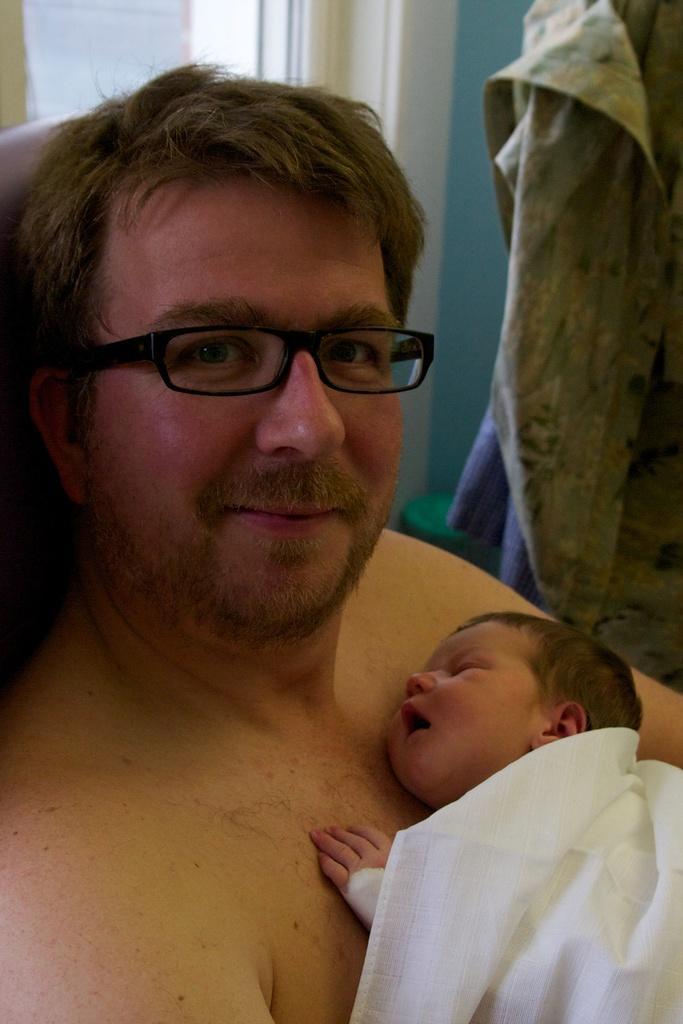How would you summarize this image in a sentence or two? In the foreground of this picture we can see a man seems to be holding a baby. In the background we can see the wall and some clothes and some other objects. 